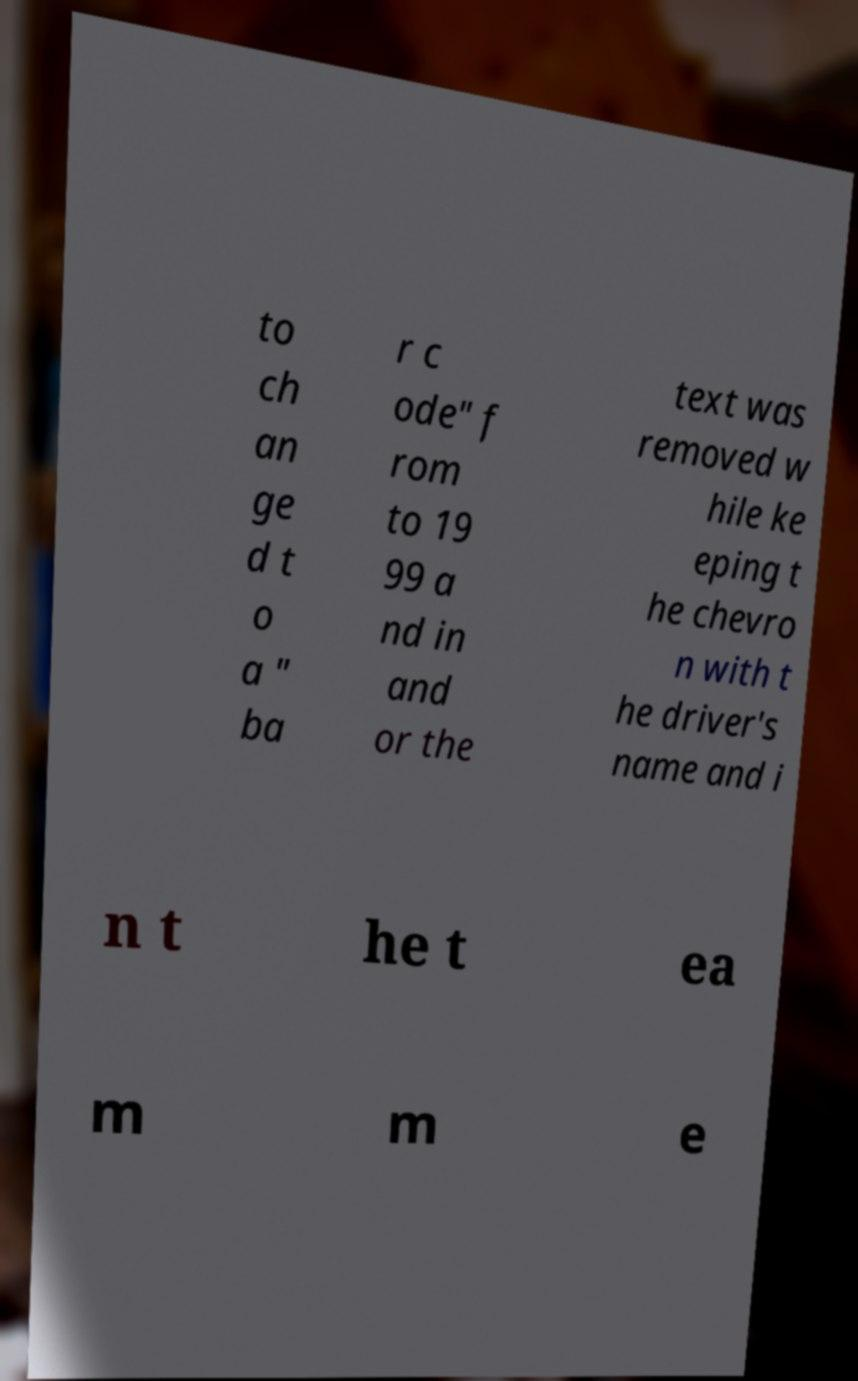Can you accurately transcribe the text from the provided image for me? to ch an ge d t o a " ba r c ode" f rom to 19 99 a nd in and or the text was removed w hile ke eping t he chevro n with t he driver's name and i n t he t ea m m e 